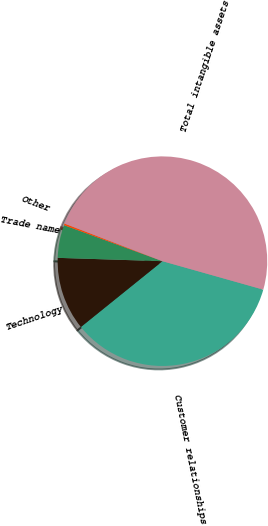<chart> <loc_0><loc_0><loc_500><loc_500><pie_chart><fcel>Customer relationships<fcel>Technology<fcel>Trade name<fcel>Other<fcel>Total intangible assets<nl><fcel>34.82%<fcel>11.31%<fcel>5.08%<fcel>0.25%<fcel>48.54%<nl></chart> 